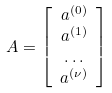<formula> <loc_0><loc_0><loc_500><loc_500>A & = \left [ \begin{array} { c } a ^ { ( 0 ) } \\ a ^ { ( 1 ) } \\ \dots \\ a ^ { ( \nu ) } \end{array} \right ]</formula> 